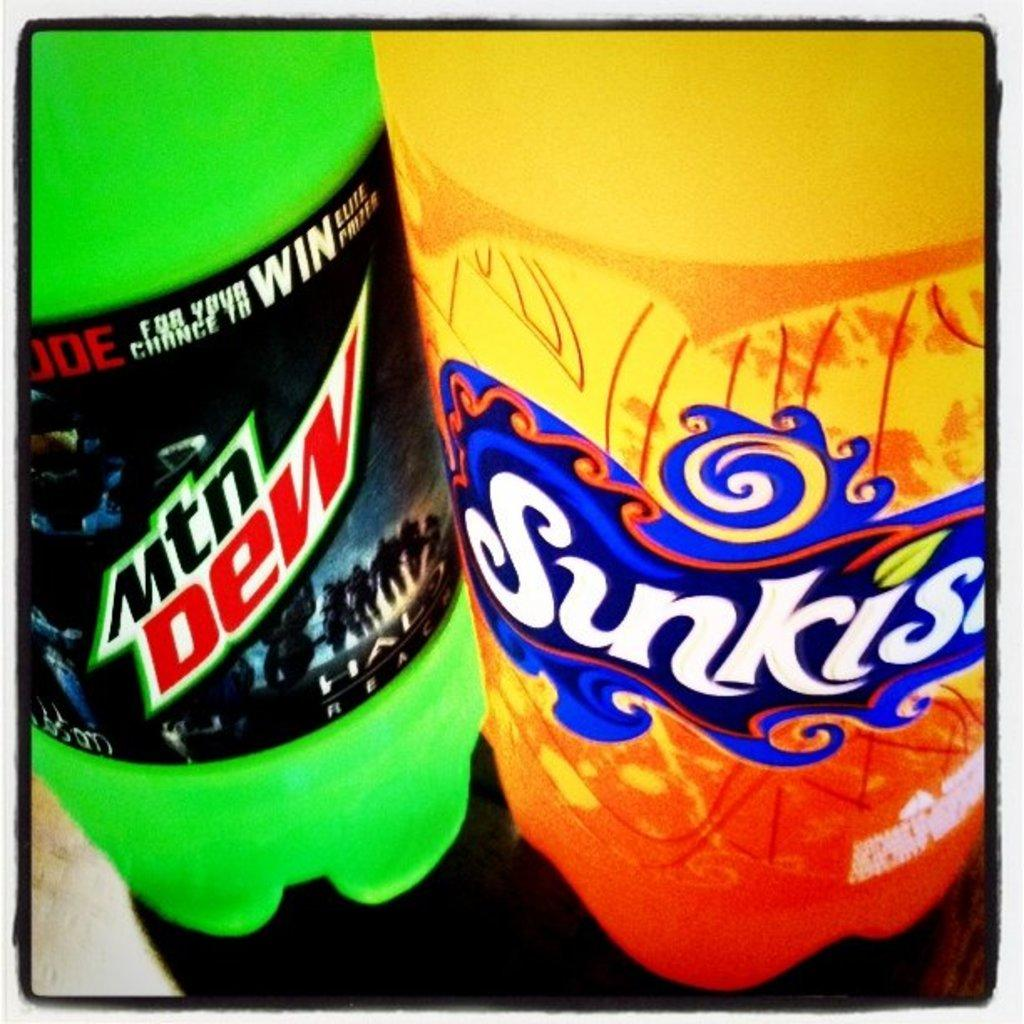How many bottles can be seen in the image? There are two bottles in the image. What type of war is depicted in the image? There is no war depicted in the image; it only contains two bottles. Can you tell me where the patch is located on the bottles? There is no patch present on the bottles in the image. 